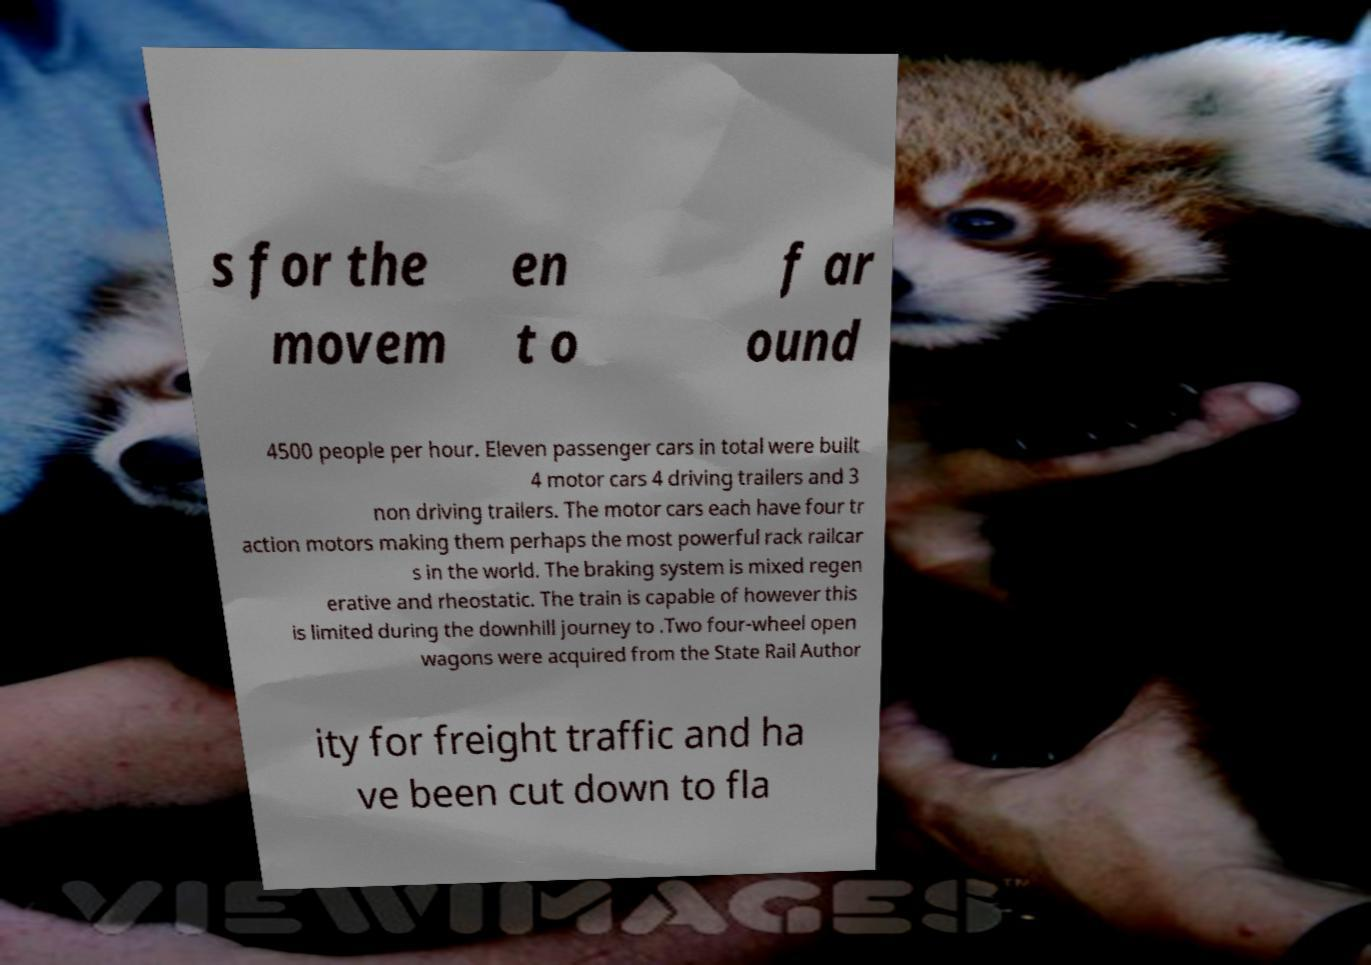Can you accurately transcribe the text from the provided image for me? s for the movem en t o f ar ound 4500 people per hour. Eleven passenger cars in total were built 4 motor cars 4 driving trailers and 3 non driving trailers. The motor cars each have four tr action motors making them perhaps the most powerful rack railcar s in the world. The braking system is mixed regen erative and rheostatic. The train is capable of however this is limited during the downhill journey to .Two four-wheel open wagons were acquired from the State Rail Author ity for freight traffic and ha ve been cut down to fla 